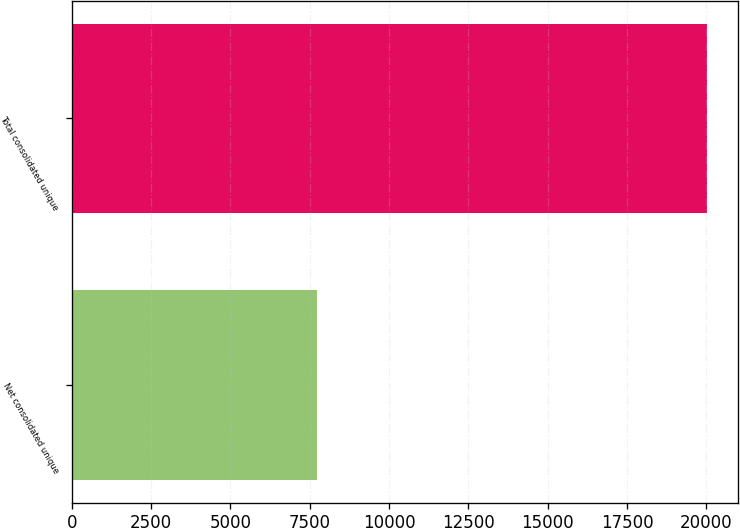Convert chart. <chart><loc_0><loc_0><loc_500><loc_500><bar_chart><fcel>Net consolidated unique<fcel>Total consolidated unique<nl><fcel>7742<fcel>20010<nl></chart> 